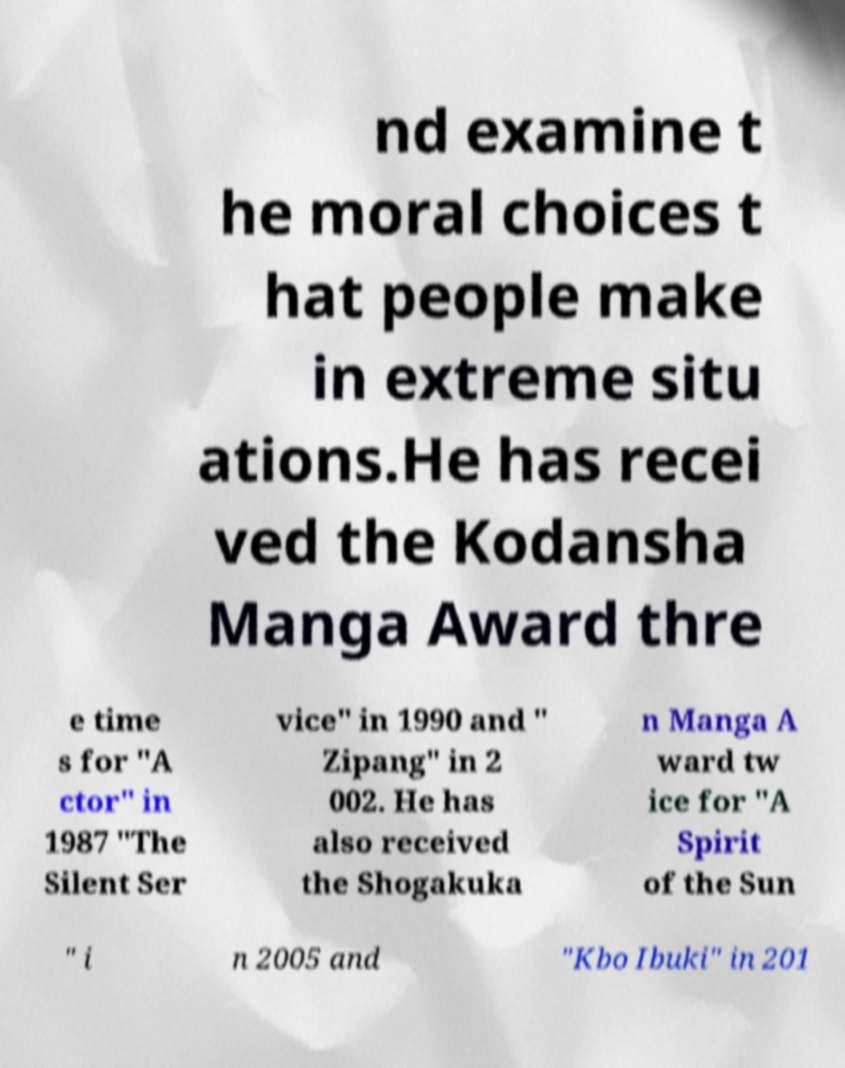For documentation purposes, I need the text within this image transcribed. Could you provide that? nd examine t he moral choices t hat people make in extreme situ ations.He has recei ved the Kodansha Manga Award thre e time s for "A ctor" in 1987 "The Silent Ser vice" in 1990 and " Zipang" in 2 002. He has also received the Shogakuka n Manga A ward tw ice for "A Spirit of the Sun " i n 2005 and "Kbo Ibuki" in 201 